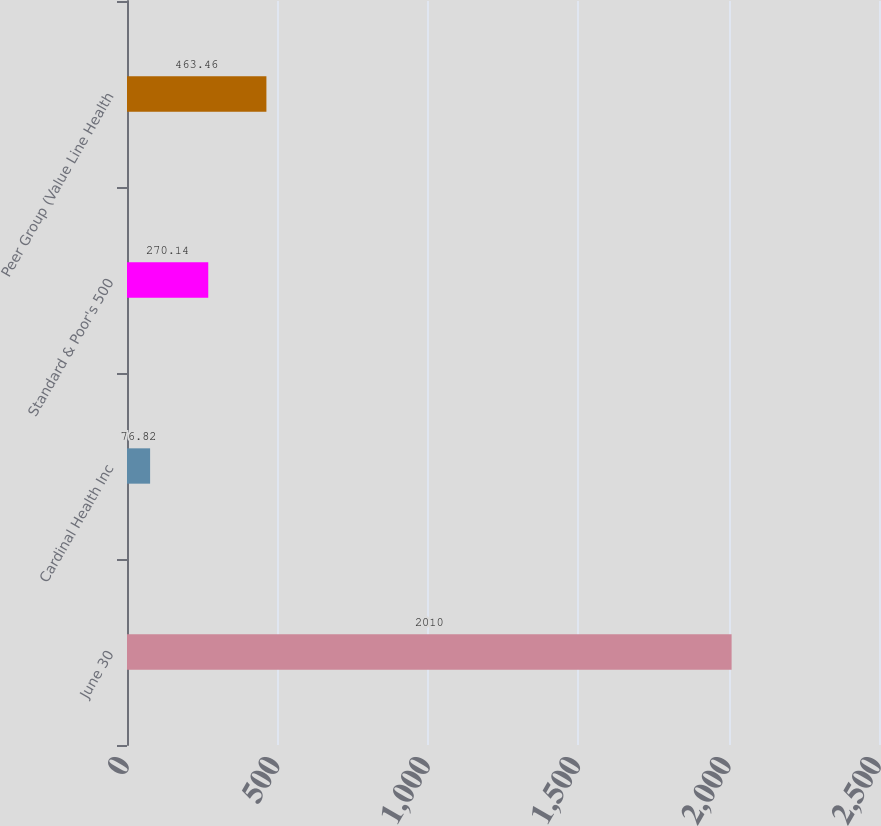Convert chart to OTSL. <chart><loc_0><loc_0><loc_500><loc_500><bar_chart><fcel>June 30<fcel>Cardinal Health Inc<fcel>Standard & Poor's 500<fcel>Peer Group (Value Line Health<nl><fcel>2010<fcel>76.82<fcel>270.14<fcel>463.46<nl></chart> 